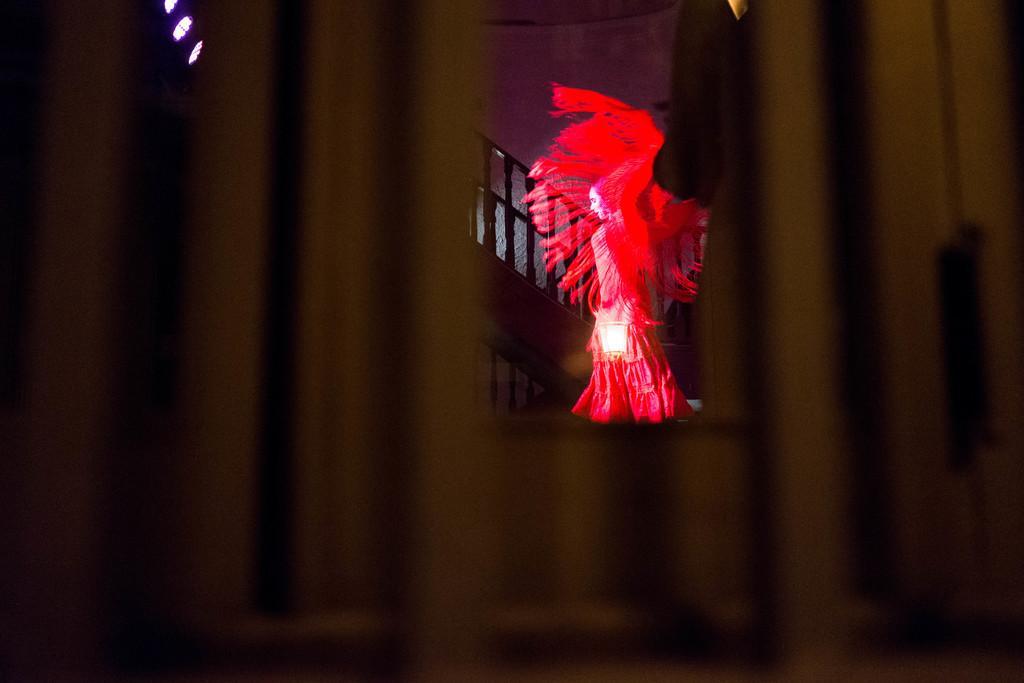Describe this image in one or two sentences. In the center of the image we can see a person wearing a costume. In the background there are stairs and a wall. 